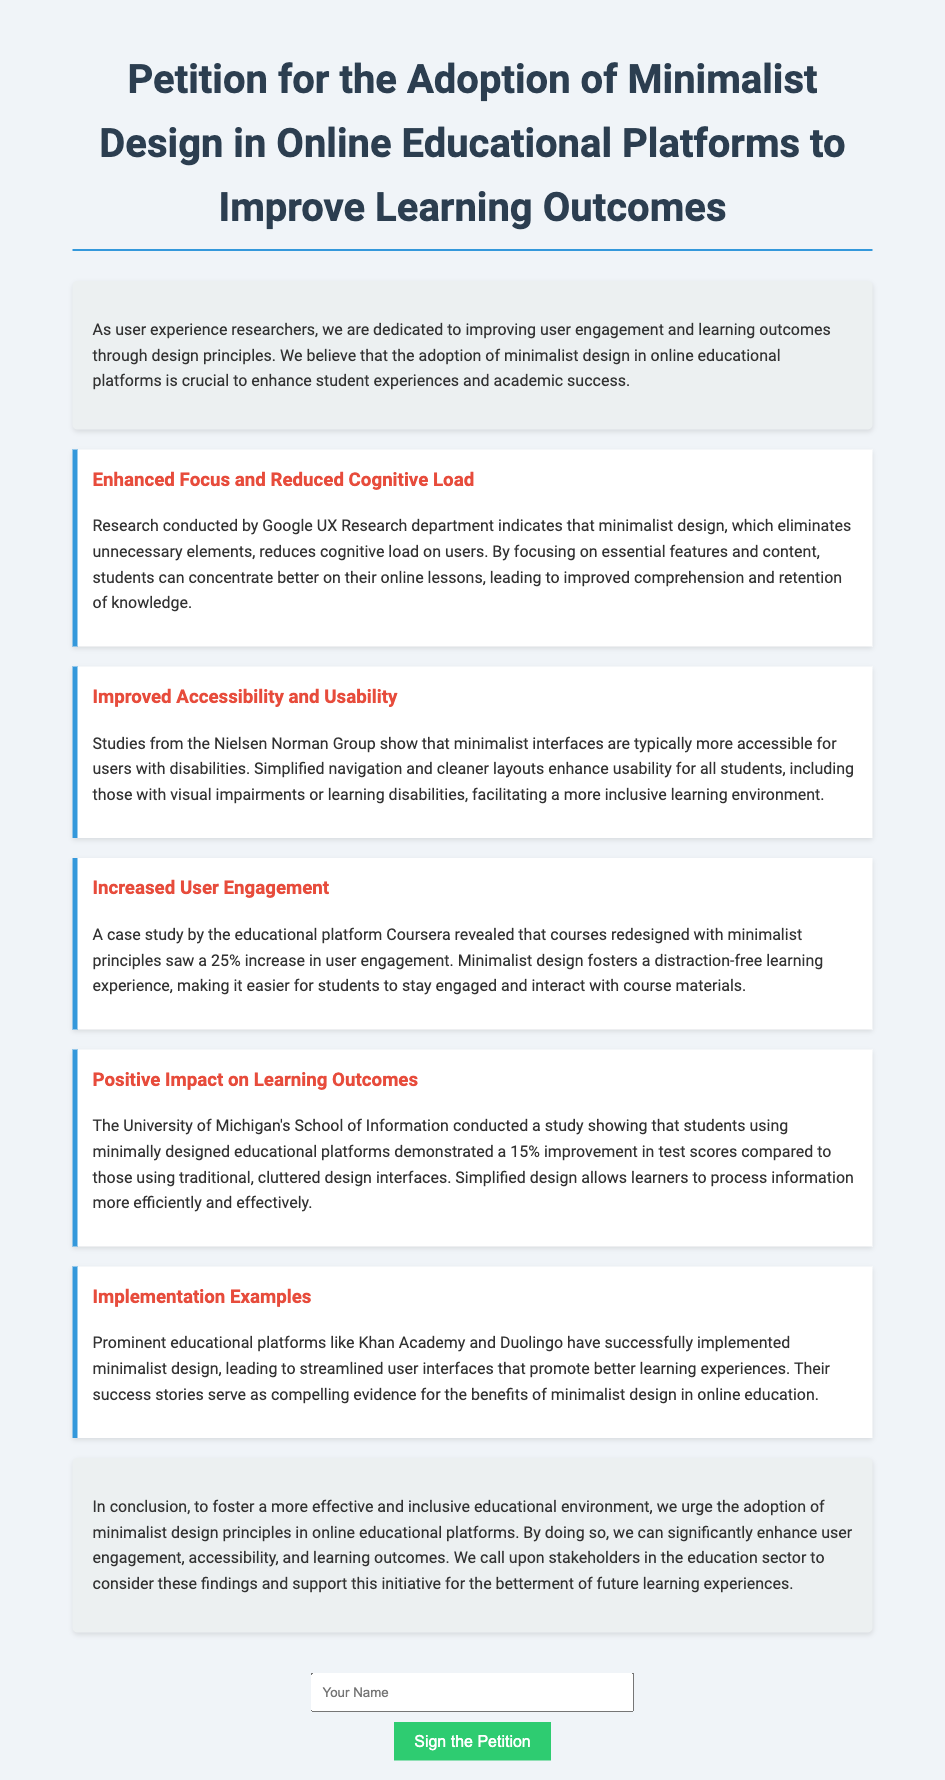What is the title of the petition? The title is mentioned at the top of the document as a central feature.
Answer: Petition for the Adoption of Minimalist Design in Online Educational Platforms to Improve Learning Outcomes What organization conducted research indicating that minimalist design reduces cognitive load? The document specifies the organization responsible for this research.
Answer: Google UX Research By how much did user engagement increase in Coursera after redesigning with minimalist principles? The document provides a specific percentage that reflects the increase in engagement.
Answer: 25% Which two educational platforms are mentioned as successfully implementing minimalist design? The document lists these platforms as examples of successful implementation.
Answer: Khan Academy and Duolingo What percentage improvement in test scores did students using minimalist design achieve? The study results are included for comparison in the document.
Answer: 15% What is one benefit of minimalist interfaces according to the Nielsen Norman Group? The document describes benefits associated with minimalist interfaces.
Answer: Improved accessibility What color is used for the heading of the conclusion section? The document describes the styling for different sections, including the conclusion.
Answer: The same color as the other headings, which is indicated but not specified in the question prompt What is the purpose of this petition? The objective is clearly stated in the introduction and conclusion of the document.
Answer: Improve learning outcomes How do stakeholders in the education sector benefit from this initiative? The document clarifies how the suggested design can affect educational stakeholders.
Answer: Enhanced user engagement, accessibility, and learning outcomes 